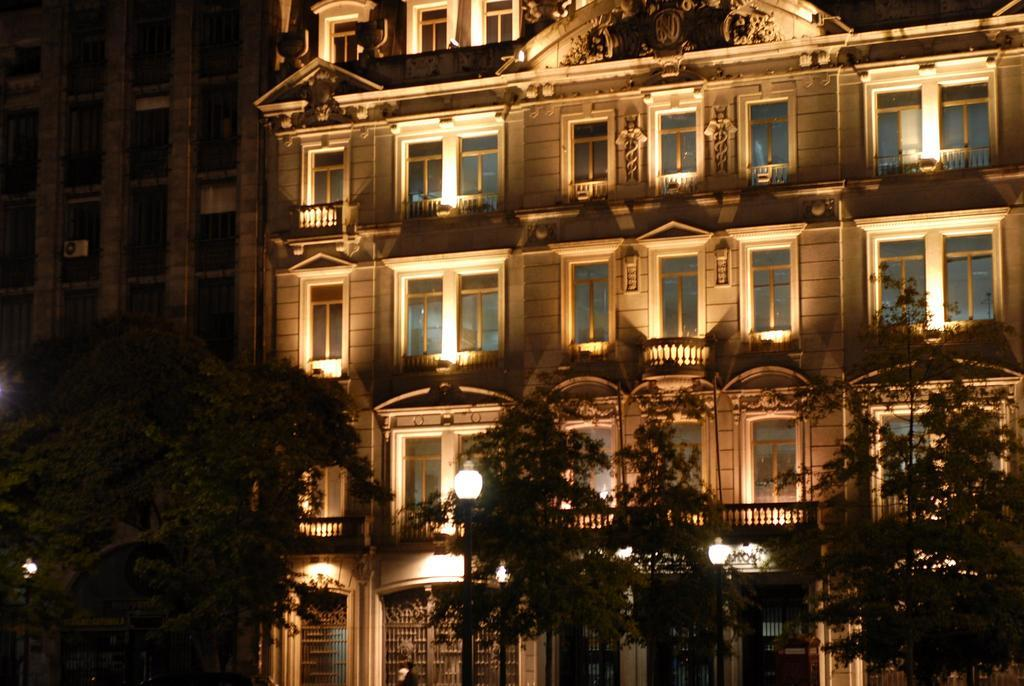What is the main structure in the center of the image? There is a building in the center of the image. What type of vegetation is present at the bottom of the image? There are trees at the bottom of the image. What are the vertical structures visible in the image? There are poles visible in the image. What can be seen illuminating the area in the image? There are lights present in the image. What type of plantation can be seen in the image? There is no plantation present in the image. Can you tell me how the church is used in the image? There is no church present in the image. 